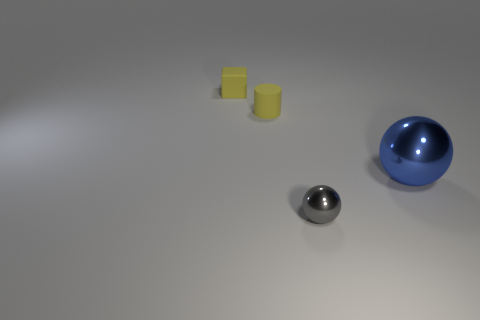Add 2 small rubber cylinders. How many objects exist? 6 Subtract all cubes. How many objects are left? 3 Add 2 gray shiny spheres. How many gray shiny spheres are left? 3 Add 3 cubes. How many cubes exist? 4 Subtract 1 yellow cylinders. How many objects are left? 3 Subtract all tiny spheres. Subtract all large blue metal blocks. How many objects are left? 3 